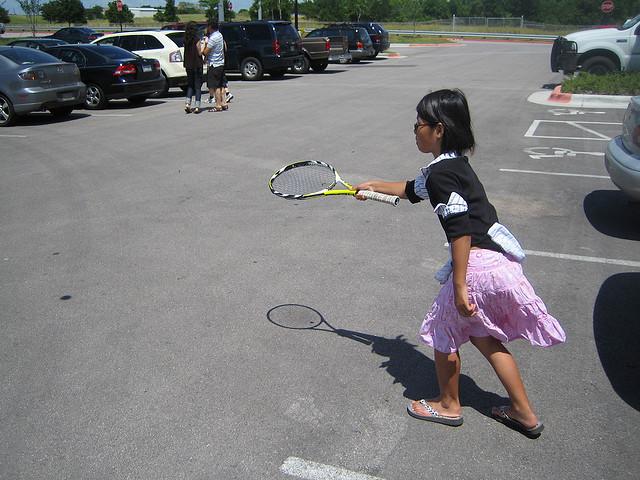Is this a bike race?
Give a very brief answer. No. Where is the blue car located?
Short answer required. Parking lot. Is the girl wearing flip flops?
Quick response, please. Yes. Is the girl wearing sneakers?
Keep it brief. No. IS this a group of people?
Short answer required. No. What is the little girl in the center standing on?
Concise answer only. Pavement. What is the girl holding in her right hand?
Quick response, please. Tennis racket. Who is the lady?
Quick response, please. Tennis player. What is painted here?
Keep it brief. Lines. Are the people relaxing?
Short answer required. Yes. 